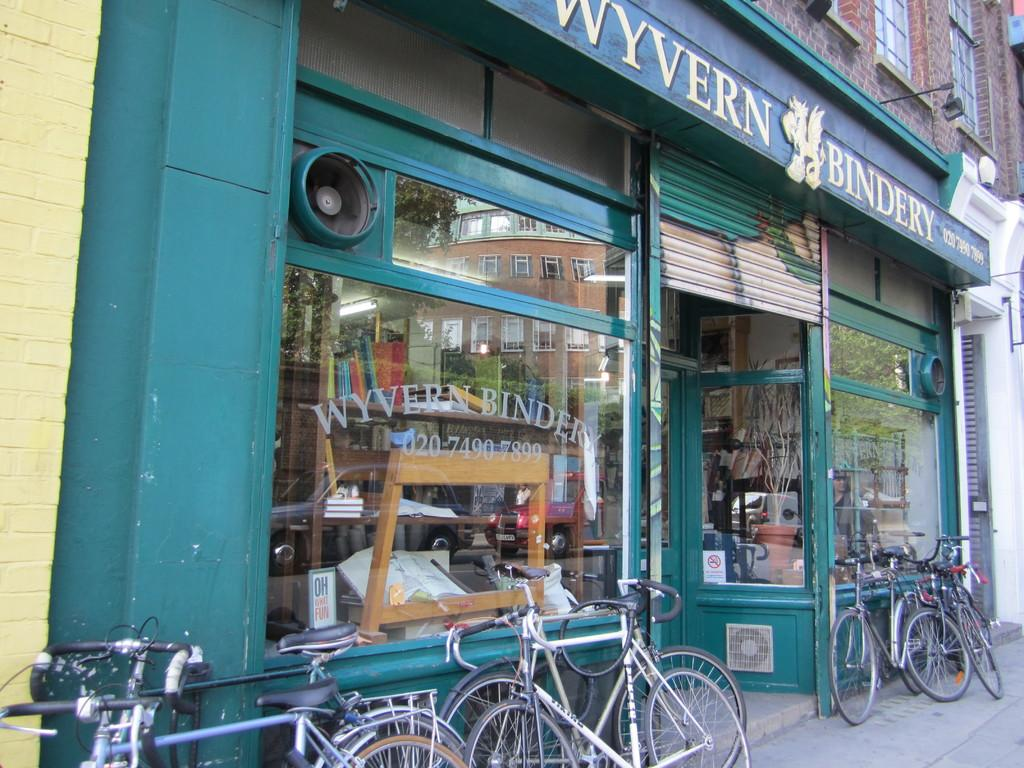<image>
Relay a brief, clear account of the picture shown. A store painted in green in the outside named "Wyvern Bindery". 